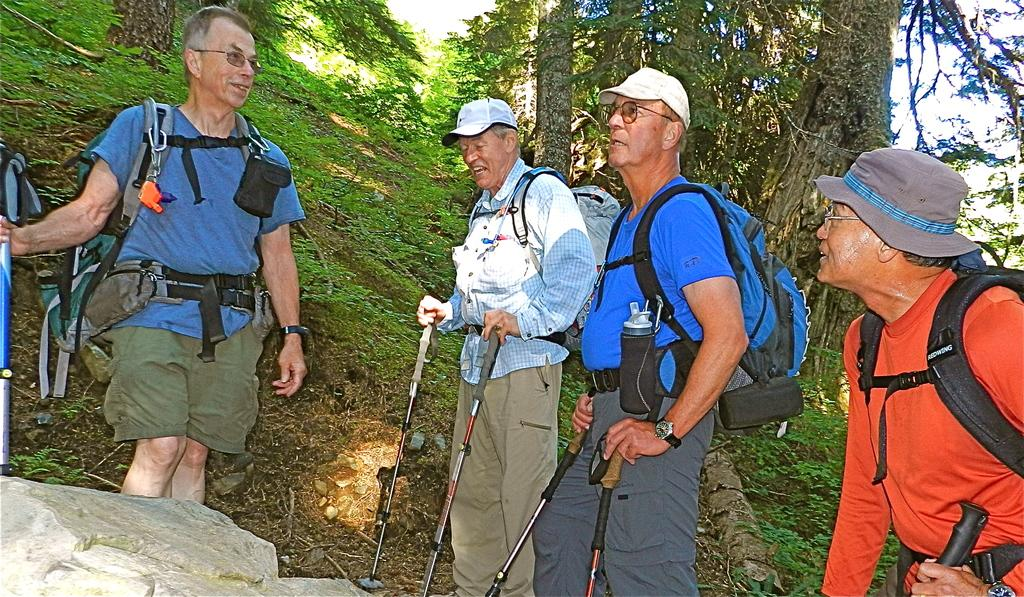Who is present in the image? There are old men in the image. Where are the old men located? The old men are standing in the forest. What items do the old men have with them? The old men have backpacks on their backs and trekking sticks. What can be seen in the background of the image? There are trees visible in the image. What time does the hen appear in the image? There is no hen present in the image. How does the shock affect the old men in the image? There is no shock or any indication of shock in the image. 